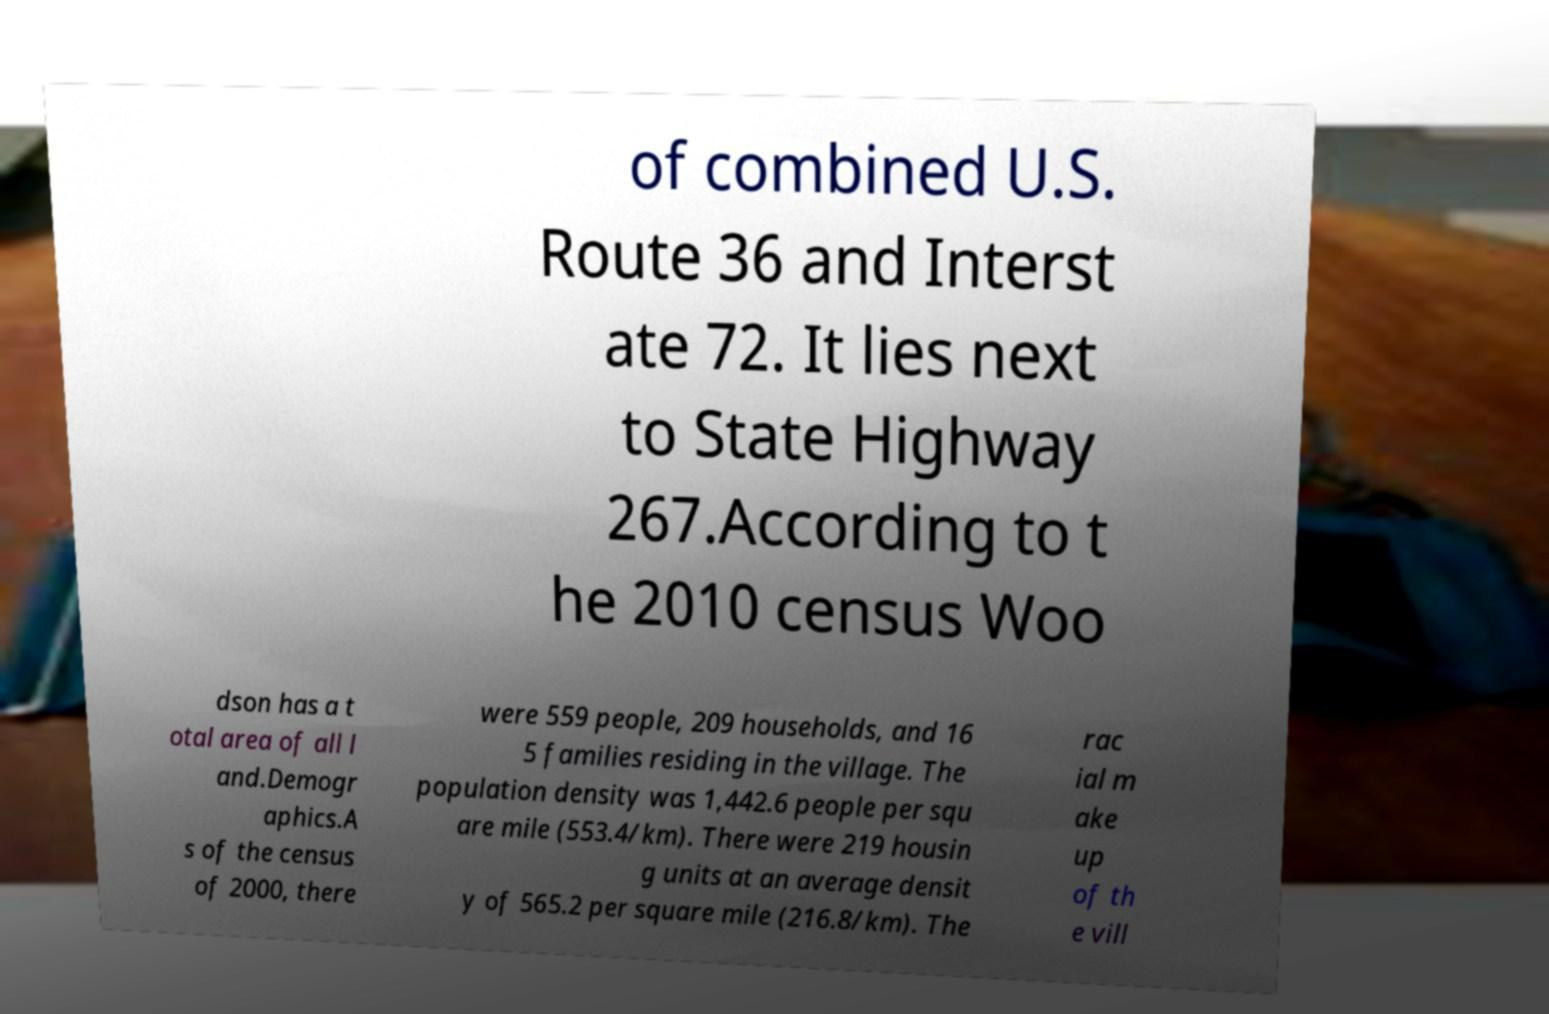There's text embedded in this image that I need extracted. Can you transcribe it verbatim? of combined U.S. Route 36 and Interst ate 72. It lies next to State Highway 267.According to t he 2010 census Woo dson has a t otal area of all l and.Demogr aphics.A s of the census of 2000, there were 559 people, 209 households, and 16 5 families residing in the village. The population density was 1,442.6 people per squ are mile (553.4/km). There were 219 housin g units at an average densit y of 565.2 per square mile (216.8/km). The rac ial m ake up of th e vill 